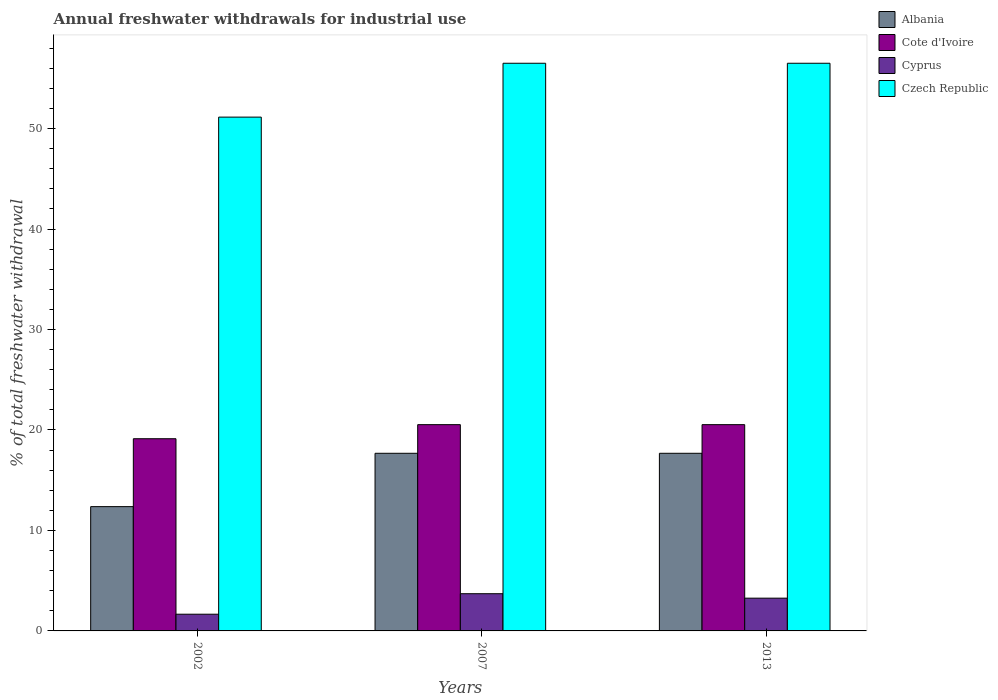How many groups of bars are there?
Offer a terse response. 3. Are the number of bars per tick equal to the number of legend labels?
Your answer should be compact. Yes. Are the number of bars on each tick of the X-axis equal?
Offer a very short reply. Yes. What is the total annual withdrawals from freshwater in Czech Republic in 2002?
Offer a very short reply. 51.14. Across all years, what is the maximum total annual withdrawals from freshwater in Cote d'Ivoire?
Provide a succinct answer. 20.53. Across all years, what is the minimum total annual withdrawals from freshwater in Cyprus?
Make the answer very short. 1.66. In which year was the total annual withdrawals from freshwater in Czech Republic minimum?
Ensure brevity in your answer.  2002. What is the total total annual withdrawals from freshwater in Czech Republic in the graph?
Make the answer very short. 164.14. What is the difference between the total annual withdrawals from freshwater in Czech Republic in 2007 and that in 2013?
Give a very brief answer. 0. What is the difference between the total annual withdrawals from freshwater in Albania in 2002 and the total annual withdrawals from freshwater in Cyprus in 2013?
Your answer should be very brief. 9.11. What is the average total annual withdrawals from freshwater in Albania per year?
Ensure brevity in your answer.  15.91. In the year 2007, what is the difference between the total annual withdrawals from freshwater in Albania and total annual withdrawals from freshwater in Czech Republic?
Provide a succinct answer. -38.82. What is the ratio of the total annual withdrawals from freshwater in Albania in 2002 to that in 2007?
Provide a succinct answer. 0.7. Is the difference between the total annual withdrawals from freshwater in Albania in 2002 and 2007 greater than the difference between the total annual withdrawals from freshwater in Czech Republic in 2002 and 2007?
Keep it short and to the point. Yes. What is the difference between the highest and the lowest total annual withdrawals from freshwater in Cote d'Ivoire?
Provide a succinct answer. 1.4. What does the 3rd bar from the left in 2007 represents?
Give a very brief answer. Cyprus. What does the 1st bar from the right in 2002 represents?
Offer a terse response. Czech Republic. Is it the case that in every year, the sum of the total annual withdrawals from freshwater in Czech Republic and total annual withdrawals from freshwater in Albania is greater than the total annual withdrawals from freshwater in Cyprus?
Offer a terse response. Yes. Are all the bars in the graph horizontal?
Provide a short and direct response. No. What is the difference between two consecutive major ticks on the Y-axis?
Make the answer very short. 10. Are the values on the major ticks of Y-axis written in scientific E-notation?
Ensure brevity in your answer.  No. Does the graph contain any zero values?
Offer a terse response. No. Does the graph contain grids?
Keep it short and to the point. No. Where does the legend appear in the graph?
Your response must be concise. Top right. How many legend labels are there?
Your response must be concise. 4. What is the title of the graph?
Ensure brevity in your answer.  Annual freshwater withdrawals for industrial use. Does "Liechtenstein" appear as one of the legend labels in the graph?
Your response must be concise. No. What is the label or title of the Y-axis?
Give a very brief answer. % of total freshwater withdrawal. What is the % of total freshwater withdrawal of Albania in 2002?
Keep it short and to the point. 12.37. What is the % of total freshwater withdrawal in Cote d'Ivoire in 2002?
Your response must be concise. 19.13. What is the % of total freshwater withdrawal in Cyprus in 2002?
Make the answer very short. 1.66. What is the % of total freshwater withdrawal of Czech Republic in 2002?
Ensure brevity in your answer.  51.14. What is the % of total freshwater withdrawal of Albania in 2007?
Your answer should be very brief. 17.68. What is the % of total freshwater withdrawal in Cote d'Ivoire in 2007?
Your answer should be compact. 20.53. What is the % of total freshwater withdrawal in Cyprus in 2007?
Provide a short and direct response. 3.7. What is the % of total freshwater withdrawal of Czech Republic in 2007?
Your response must be concise. 56.5. What is the % of total freshwater withdrawal in Albania in 2013?
Make the answer very short. 17.68. What is the % of total freshwater withdrawal in Cote d'Ivoire in 2013?
Give a very brief answer. 20.53. What is the % of total freshwater withdrawal in Cyprus in 2013?
Give a very brief answer. 3.26. What is the % of total freshwater withdrawal of Czech Republic in 2013?
Offer a terse response. 56.5. Across all years, what is the maximum % of total freshwater withdrawal of Albania?
Your answer should be very brief. 17.68. Across all years, what is the maximum % of total freshwater withdrawal in Cote d'Ivoire?
Keep it short and to the point. 20.53. Across all years, what is the maximum % of total freshwater withdrawal in Cyprus?
Offer a terse response. 3.7. Across all years, what is the maximum % of total freshwater withdrawal in Czech Republic?
Offer a very short reply. 56.5. Across all years, what is the minimum % of total freshwater withdrawal of Albania?
Give a very brief answer. 12.37. Across all years, what is the minimum % of total freshwater withdrawal in Cote d'Ivoire?
Your response must be concise. 19.13. Across all years, what is the minimum % of total freshwater withdrawal of Cyprus?
Make the answer very short. 1.66. Across all years, what is the minimum % of total freshwater withdrawal in Czech Republic?
Provide a succinct answer. 51.14. What is the total % of total freshwater withdrawal of Albania in the graph?
Ensure brevity in your answer.  47.73. What is the total % of total freshwater withdrawal of Cote d'Ivoire in the graph?
Provide a succinct answer. 60.19. What is the total % of total freshwater withdrawal in Cyprus in the graph?
Your answer should be very brief. 8.63. What is the total % of total freshwater withdrawal in Czech Republic in the graph?
Your answer should be compact. 164.14. What is the difference between the % of total freshwater withdrawal in Albania in 2002 and that in 2007?
Keep it short and to the point. -5.31. What is the difference between the % of total freshwater withdrawal of Cote d'Ivoire in 2002 and that in 2007?
Give a very brief answer. -1.4. What is the difference between the % of total freshwater withdrawal in Cyprus in 2002 and that in 2007?
Provide a short and direct response. -2.04. What is the difference between the % of total freshwater withdrawal in Czech Republic in 2002 and that in 2007?
Your answer should be compact. -5.36. What is the difference between the % of total freshwater withdrawal of Albania in 2002 and that in 2013?
Your answer should be very brief. -5.31. What is the difference between the % of total freshwater withdrawal of Cote d'Ivoire in 2002 and that in 2013?
Give a very brief answer. -1.4. What is the difference between the % of total freshwater withdrawal in Cyprus in 2002 and that in 2013?
Ensure brevity in your answer.  -1.6. What is the difference between the % of total freshwater withdrawal of Czech Republic in 2002 and that in 2013?
Offer a very short reply. -5.36. What is the difference between the % of total freshwater withdrawal of Cyprus in 2007 and that in 2013?
Your answer should be very brief. 0.44. What is the difference between the % of total freshwater withdrawal in Czech Republic in 2007 and that in 2013?
Your answer should be compact. 0. What is the difference between the % of total freshwater withdrawal in Albania in 2002 and the % of total freshwater withdrawal in Cote d'Ivoire in 2007?
Your response must be concise. -8.16. What is the difference between the % of total freshwater withdrawal in Albania in 2002 and the % of total freshwater withdrawal in Cyprus in 2007?
Make the answer very short. 8.67. What is the difference between the % of total freshwater withdrawal in Albania in 2002 and the % of total freshwater withdrawal in Czech Republic in 2007?
Provide a succinct answer. -44.13. What is the difference between the % of total freshwater withdrawal of Cote d'Ivoire in 2002 and the % of total freshwater withdrawal of Cyprus in 2007?
Provide a succinct answer. 15.43. What is the difference between the % of total freshwater withdrawal of Cote d'Ivoire in 2002 and the % of total freshwater withdrawal of Czech Republic in 2007?
Make the answer very short. -37.37. What is the difference between the % of total freshwater withdrawal of Cyprus in 2002 and the % of total freshwater withdrawal of Czech Republic in 2007?
Keep it short and to the point. -54.84. What is the difference between the % of total freshwater withdrawal in Albania in 2002 and the % of total freshwater withdrawal in Cote d'Ivoire in 2013?
Give a very brief answer. -8.16. What is the difference between the % of total freshwater withdrawal in Albania in 2002 and the % of total freshwater withdrawal in Cyprus in 2013?
Offer a terse response. 9.11. What is the difference between the % of total freshwater withdrawal of Albania in 2002 and the % of total freshwater withdrawal of Czech Republic in 2013?
Offer a terse response. -44.13. What is the difference between the % of total freshwater withdrawal in Cote d'Ivoire in 2002 and the % of total freshwater withdrawal in Cyprus in 2013?
Ensure brevity in your answer.  15.87. What is the difference between the % of total freshwater withdrawal in Cote d'Ivoire in 2002 and the % of total freshwater withdrawal in Czech Republic in 2013?
Your response must be concise. -37.37. What is the difference between the % of total freshwater withdrawal in Cyprus in 2002 and the % of total freshwater withdrawal in Czech Republic in 2013?
Keep it short and to the point. -54.84. What is the difference between the % of total freshwater withdrawal in Albania in 2007 and the % of total freshwater withdrawal in Cote d'Ivoire in 2013?
Your answer should be very brief. -2.85. What is the difference between the % of total freshwater withdrawal of Albania in 2007 and the % of total freshwater withdrawal of Cyprus in 2013?
Your answer should be very brief. 14.42. What is the difference between the % of total freshwater withdrawal in Albania in 2007 and the % of total freshwater withdrawal in Czech Republic in 2013?
Ensure brevity in your answer.  -38.82. What is the difference between the % of total freshwater withdrawal in Cote d'Ivoire in 2007 and the % of total freshwater withdrawal in Cyprus in 2013?
Provide a short and direct response. 17.27. What is the difference between the % of total freshwater withdrawal of Cote d'Ivoire in 2007 and the % of total freshwater withdrawal of Czech Republic in 2013?
Your answer should be compact. -35.97. What is the difference between the % of total freshwater withdrawal of Cyprus in 2007 and the % of total freshwater withdrawal of Czech Republic in 2013?
Your answer should be very brief. -52.8. What is the average % of total freshwater withdrawal of Albania per year?
Give a very brief answer. 15.91. What is the average % of total freshwater withdrawal in Cote d'Ivoire per year?
Give a very brief answer. 20.06. What is the average % of total freshwater withdrawal of Cyprus per year?
Your answer should be compact. 2.88. What is the average % of total freshwater withdrawal of Czech Republic per year?
Your answer should be compact. 54.71. In the year 2002, what is the difference between the % of total freshwater withdrawal in Albania and % of total freshwater withdrawal in Cote d'Ivoire?
Offer a terse response. -6.76. In the year 2002, what is the difference between the % of total freshwater withdrawal of Albania and % of total freshwater withdrawal of Cyprus?
Your response must be concise. 10.71. In the year 2002, what is the difference between the % of total freshwater withdrawal in Albania and % of total freshwater withdrawal in Czech Republic?
Your answer should be compact. -38.77. In the year 2002, what is the difference between the % of total freshwater withdrawal in Cote d'Ivoire and % of total freshwater withdrawal in Cyprus?
Provide a succinct answer. 17.47. In the year 2002, what is the difference between the % of total freshwater withdrawal of Cote d'Ivoire and % of total freshwater withdrawal of Czech Republic?
Ensure brevity in your answer.  -32.01. In the year 2002, what is the difference between the % of total freshwater withdrawal of Cyprus and % of total freshwater withdrawal of Czech Republic?
Give a very brief answer. -49.48. In the year 2007, what is the difference between the % of total freshwater withdrawal of Albania and % of total freshwater withdrawal of Cote d'Ivoire?
Keep it short and to the point. -2.85. In the year 2007, what is the difference between the % of total freshwater withdrawal in Albania and % of total freshwater withdrawal in Cyprus?
Offer a terse response. 13.98. In the year 2007, what is the difference between the % of total freshwater withdrawal in Albania and % of total freshwater withdrawal in Czech Republic?
Your answer should be compact. -38.82. In the year 2007, what is the difference between the % of total freshwater withdrawal in Cote d'Ivoire and % of total freshwater withdrawal in Cyprus?
Keep it short and to the point. 16.83. In the year 2007, what is the difference between the % of total freshwater withdrawal in Cote d'Ivoire and % of total freshwater withdrawal in Czech Republic?
Provide a succinct answer. -35.97. In the year 2007, what is the difference between the % of total freshwater withdrawal of Cyprus and % of total freshwater withdrawal of Czech Republic?
Offer a very short reply. -52.8. In the year 2013, what is the difference between the % of total freshwater withdrawal of Albania and % of total freshwater withdrawal of Cote d'Ivoire?
Provide a succinct answer. -2.85. In the year 2013, what is the difference between the % of total freshwater withdrawal in Albania and % of total freshwater withdrawal in Cyprus?
Provide a succinct answer. 14.42. In the year 2013, what is the difference between the % of total freshwater withdrawal of Albania and % of total freshwater withdrawal of Czech Republic?
Offer a very short reply. -38.82. In the year 2013, what is the difference between the % of total freshwater withdrawal of Cote d'Ivoire and % of total freshwater withdrawal of Cyprus?
Keep it short and to the point. 17.27. In the year 2013, what is the difference between the % of total freshwater withdrawal in Cote d'Ivoire and % of total freshwater withdrawal in Czech Republic?
Make the answer very short. -35.97. In the year 2013, what is the difference between the % of total freshwater withdrawal in Cyprus and % of total freshwater withdrawal in Czech Republic?
Make the answer very short. -53.24. What is the ratio of the % of total freshwater withdrawal in Albania in 2002 to that in 2007?
Ensure brevity in your answer.  0.7. What is the ratio of the % of total freshwater withdrawal of Cote d'Ivoire in 2002 to that in 2007?
Provide a short and direct response. 0.93. What is the ratio of the % of total freshwater withdrawal of Cyprus in 2002 to that in 2007?
Offer a very short reply. 0.45. What is the ratio of the % of total freshwater withdrawal in Czech Republic in 2002 to that in 2007?
Ensure brevity in your answer.  0.91. What is the ratio of the % of total freshwater withdrawal of Albania in 2002 to that in 2013?
Ensure brevity in your answer.  0.7. What is the ratio of the % of total freshwater withdrawal of Cote d'Ivoire in 2002 to that in 2013?
Your response must be concise. 0.93. What is the ratio of the % of total freshwater withdrawal in Cyprus in 2002 to that in 2013?
Your answer should be compact. 0.51. What is the ratio of the % of total freshwater withdrawal of Czech Republic in 2002 to that in 2013?
Provide a short and direct response. 0.91. What is the ratio of the % of total freshwater withdrawal of Albania in 2007 to that in 2013?
Your response must be concise. 1. What is the ratio of the % of total freshwater withdrawal in Cyprus in 2007 to that in 2013?
Keep it short and to the point. 1.14. What is the difference between the highest and the second highest % of total freshwater withdrawal in Cote d'Ivoire?
Keep it short and to the point. 0. What is the difference between the highest and the second highest % of total freshwater withdrawal of Cyprus?
Your answer should be very brief. 0.44. What is the difference between the highest and the second highest % of total freshwater withdrawal in Czech Republic?
Ensure brevity in your answer.  0. What is the difference between the highest and the lowest % of total freshwater withdrawal of Albania?
Offer a terse response. 5.31. What is the difference between the highest and the lowest % of total freshwater withdrawal in Cote d'Ivoire?
Your answer should be very brief. 1.4. What is the difference between the highest and the lowest % of total freshwater withdrawal of Cyprus?
Give a very brief answer. 2.04. What is the difference between the highest and the lowest % of total freshwater withdrawal of Czech Republic?
Provide a succinct answer. 5.36. 